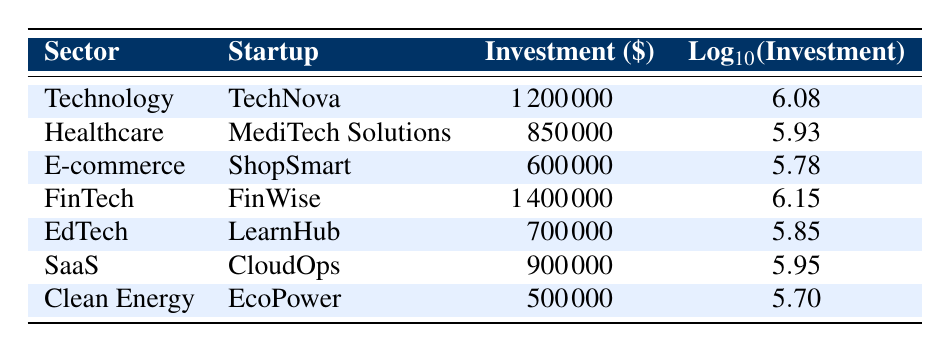What is the highest investment received by a startup? The table lists various startups with their investment amounts. The highest investment is 1,400,000 from FinWise in the FinTech sector.
Answer: 1,400,000 Which sector has the lowest investment amount? Among the listed sectors, Clean Energy, with EcoPower receiving 500,000, has the lowest investment.
Answer: Clean Energy What is the average investment received by the startups listed? To find the average, we sum the investments: 1,200,000 + 850,000 + 600,000 + 1,400,000 + 700,000 + 900,000 + 500,000 = 6,150,000. There are 7 startups, so the average is 6,150,000 / 7 = 878,571.43.
Answer: 878,571.43 Is there any startup that received an investment of 1 million or more? By examining the table, TechNova, FinWise, and CloudOps received investments of 1,200,000, 1,400,000, and 900,000 respectively. Since TechNova and FinWise are over 1 million, the answer is yes.
Answer: Yes What is the total investment received by the Technology and E-commerce sectors combined? The investments from Technology (1,200,000) and E-commerce (600,000) are combined. The total is 1,200,000 + 600,000 = 1,800,000.
Answer: 1,800,000 Which startup has an investment closest to 1 million? Among the startups, CloudOps received 900,000, which is the closest to 1 million, less than by 100,000.
Answer: CloudOps Were investments in the Healthcare and EdTech sectors both more than 600,000? The Healthcare sector received 850,000, and the EdTech sector received 700,000. Both amounts exceed 600,000, therefore the answer is yes.
Answer: Yes If we consider only the SaaS and Clean Energy sectors, what is the difference in their investment amounts? The investment for SaaS (900,000) minus Clean Energy (500,000) equals a difference of 900,000 - 500,000 = 400,000.
Answer: 400,000 What is the investment ratio of FinTech to the total investment? The total investment is 6,150,000, and FinTech received 1,400,000. The ratio is 1,400,000 / 6,150,000 = 0.227. Therefore, the investment in FinTech constitutes approximately 22.7% of the total.
Answer: 0.227 